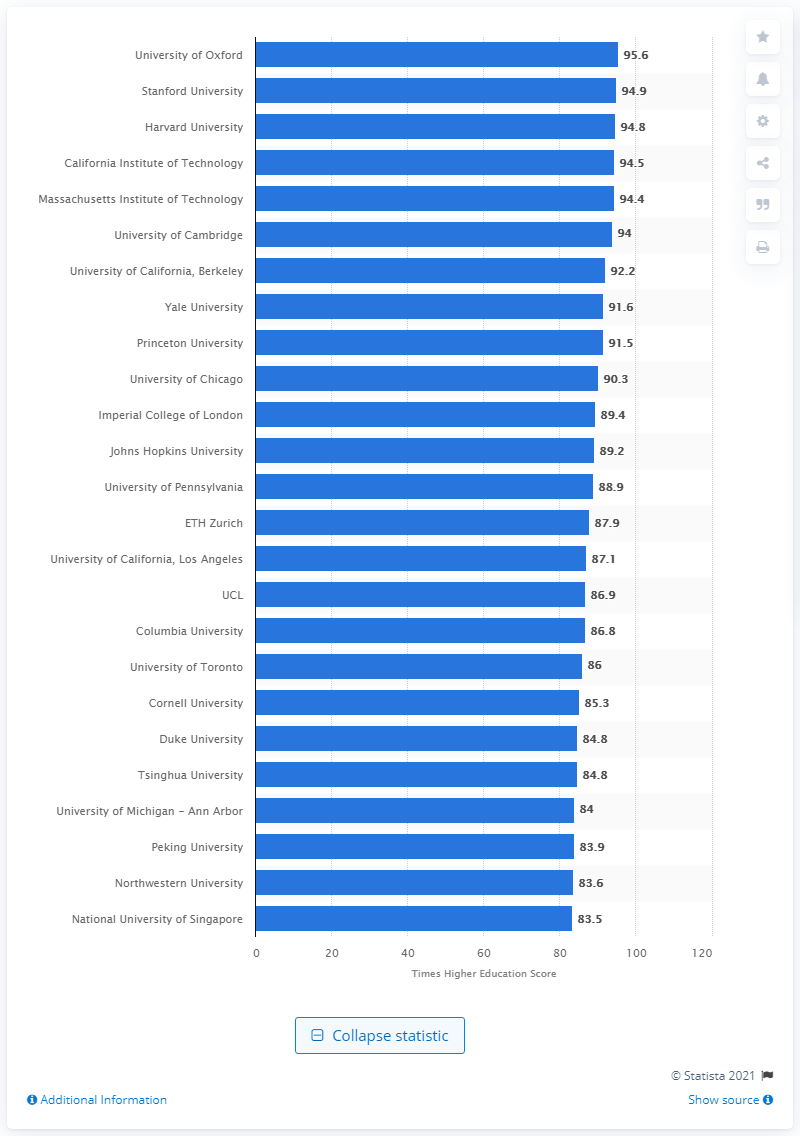List a handful of essential elements in this visual. The score of the University of Oxford was 95.6.. 